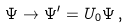Convert formula to latex. <formula><loc_0><loc_0><loc_500><loc_500>\Psi \rightarrow \Psi ^ { \prime } = U _ { 0 } \Psi \, ,</formula> 